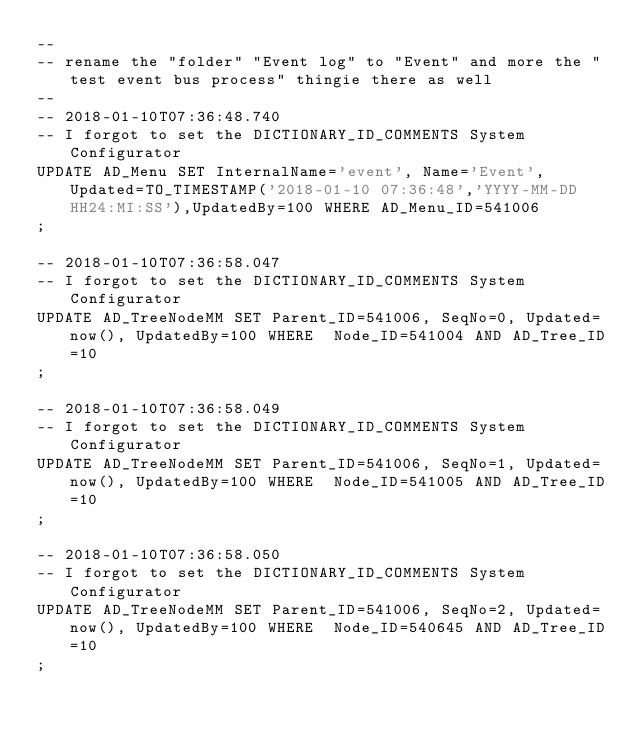Convert code to text. <code><loc_0><loc_0><loc_500><loc_500><_SQL_>--
-- rename the "folder" "Event log" to "Event" and more the "test event bus process" thingie there as well
--
-- 2018-01-10T07:36:48.740
-- I forgot to set the DICTIONARY_ID_COMMENTS System Configurator
UPDATE AD_Menu SET InternalName='event', Name='Event',Updated=TO_TIMESTAMP('2018-01-10 07:36:48','YYYY-MM-DD HH24:MI:SS'),UpdatedBy=100 WHERE AD_Menu_ID=541006
;

-- 2018-01-10T07:36:58.047
-- I forgot to set the DICTIONARY_ID_COMMENTS System Configurator
UPDATE AD_TreeNodeMM SET Parent_ID=541006, SeqNo=0, Updated=now(), UpdatedBy=100 WHERE  Node_ID=541004 AND AD_Tree_ID=10
;

-- 2018-01-10T07:36:58.049
-- I forgot to set the DICTIONARY_ID_COMMENTS System Configurator
UPDATE AD_TreeNodeMM SET Parent_ID=541006, SeqNo=1, Updated=now(), UpdatedBy=100 WHERE  Node_ID=541005 AND AD_Tree_ID=10
;

-- 2018-01-10T07:36:58.050
-- I forgot to set the DICTIONARY_ID_COMMENTS System Configurator
UPDATE AD_TreeNodeMM SET Parent_ID=541006, SeqNo=2, Updated=now(), UpdatedBy=100 WHERE  Node_ID=540645 AND AD_Tree_ID=10
;

</code> 